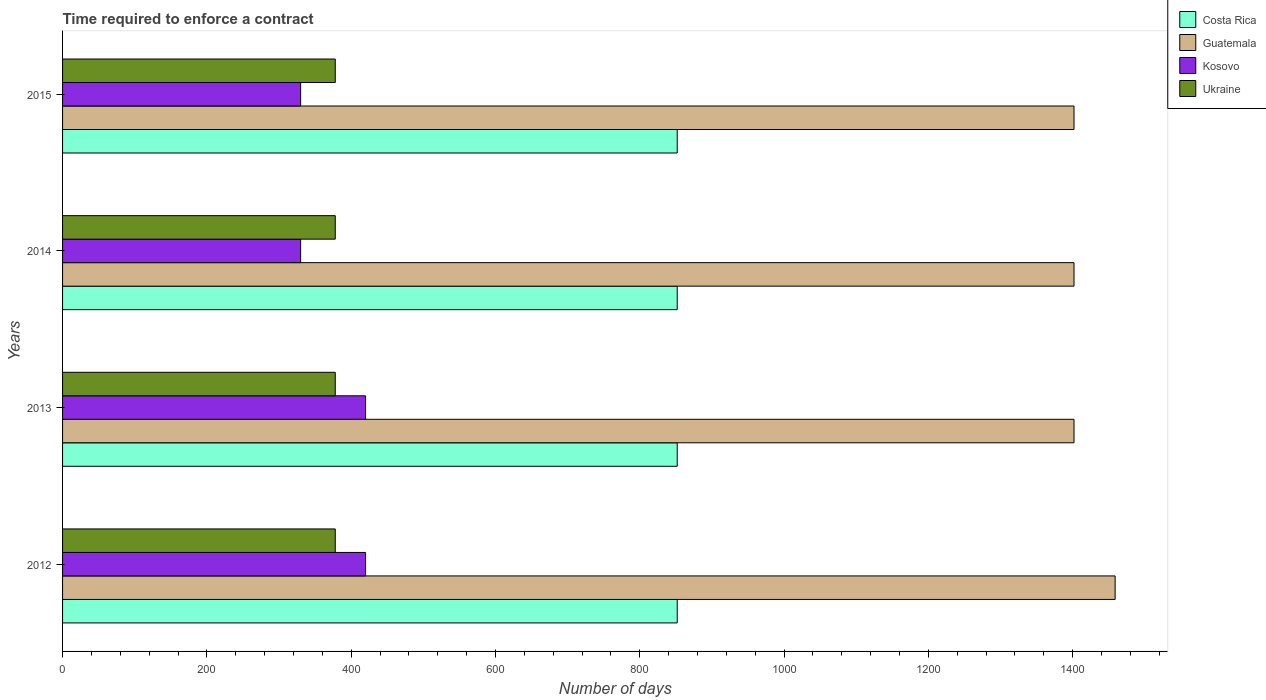Are the number of bars per tick equal to the number of legend labels?
Your answer should be compact. Yes. What is the label of the 4th group of bars from the top?
Offer a terse response. 2012. What is the number of days required to enforce a contract in Guatemala in 2014?
Your response must be concise. 1402. Across all years, what is the maximum number of days required to enforce a contract in Ukraine?
Give a very brief answer. 378. Across all years, what is the minimum number of days required to enforce a contract in Kosovo?
Ensure brevity in your answer.  330. In which year was the number of days required to enforce a contract in Guatemala maximum?
Make the answer very short. 2012. What is the total number of days required to enforce a contract in Ukraine in the graph?
Your answer should be compact. 1512. What is the difference between the number of days required to enforce a contract in Kosovo in 2014 and the number of days required to enforce a contract in Ukraine in 2013?
Provide a succinct answer. -48. What is the average number of days required to enforce a contract in Costa Rica per year?
Your response must be concise. 852. In the year 2014, what is the difference between the number of days required to enforce a contract in Ukraine and number of days required to enforce a contract in Costa Rica?
Provide a succinct answer. -474. What is the ratio of the number of days required to enforce a contract in Kosovo in 2012 to that in 2013?
Make the answer very short. 1. Is the difference between the number of days required to enforce a contract in Ukraine in 2013 and 2015 greater than the difference between the number of days required to enforce a contract in Costa Rica in 2013 and 2015?
Make the answer very short. No. What is the difference between the highest and the lowest number of days required to enforce a contract in Ukraine?
Provide a short and direct response. 0. Is the sum of the number of days required to enforce a contract in Kosovo in 2013 and 2015 greater than the maximum number of days required to enforce a contract in Guatemala across all years?
Your response must be concise. No. What does the 2nd bar from the top in 2014 represents?
Provide a short and direct response. Kosovo. What does the 4th bar from the bottom in 2014 represents?
Your response must be concise. Ukraine. Are all the bars in the graph horizontal?
Ensure brevity in your answer.  Yes. What is the difference between two consecutive major ticks on the X-axis?
Ensure brevity in your answer.  200. How many legend labels are there?
Keep it short and to the point. 4. How are the legend labels stacked?
Keep it short and to the point. Vertical. What is the title of the graph?
Offer a terse response. Time required to enforce a contract. Does "Saudi Arabia" appear as one of the legend labels in the graph?
Ensure brevity in your answer.  No. What is the label or title of the X-axis?
Ensure brevity in your answer.  Number of days. What is the label or title of the Y-axis?
Provide a succinct answer. Years. What is the Number of days in Costa Rica in 2012?
Make the answer very short. 852. What is the Number of days of Guatemala in 2012?
Keep it short and to the point. 1459. What is the Number of days of Kosovo in 2012?
Offer a very short reply. 420. What is the Number of days of Ukraine in 2012?
Offer a very short reply. 378. What is the Number of days in Costa Rica in 2013?
Make the answer very short. 852. What is the Number of days in Guatemala in 2013?
Provide a short and direct response. 1402. What is the Number of days in Kosovo in 2013?
Give a very brief answer. 420. What is the Number of days in Ukraine in 2013?
Offer a very short reply. 378. What is the Number of days in Costa Rica in 2014?
Offer a very short reply. 852. What is the Number of days in Guatemala in 2014?
Give a very brief answer. 1402. What is the Number of days in Kosovo in 2014?
Your answer should be compact. 330. What is the Number of days of Ukraine in 2014?
Provide a succinct answer. 378. What is the Number of days of Costa Rica in 2015?
Keep it short and to the point. 852. What is the Number of days in Guatemala in 2015?
Offer a terse response. 1402. What is the Number of days in Kosovo in 2015?
Your answer should be very brief. 330. What is the Number of days of Ukraine in 2015?
Your response must be concise. 378. Across all years, what is the maximum Number of days of Costa Rica?
Offer a terse response. 852. Across all years, what is the maximum Number of days of Guatemala?
Provide a succinct answer. 1459. Across all years, what is the maximum Number of days of Kosovo?
Keep it short and to the point. 420. Across all years, what is the maximum Number of days of Ukraine?
Provide a short and direct response. 378. Across all years, what is the minimum Number of days in Costa Rica?
Ensure brevity in your answer.  852. Across all years, what is the minimum Number of days in Guatemala?
Your answer should be compact. 1402. Across all years, what is the minimum Number of days in Kosovo?
Your response must be concise. 330. Across all years, what is the minimum Number of days of Ukraine?
Your answer should be compact. 378. What is the total Number of days in Costa Rica in the graph?
Your answer should be very brief. 3408. What is the total Number of days of Guatemala in the graph?
Your answer should be very brief. 5665. What is the total Number of days of Kosovo in the graph?
Your response must be concise. 1500. What is the total Number of days of Ukraine in the graph?
Your answer should be very brief. 1512. What is the difference between the Number of days in Costa Rica in 2012 and that in 2014?
Offer a terse response. 0. What is the difference between the Number of days of Guatemala in 2012 and that in 2014?
Offer a very short reply. 57. What is the difference between the Number of days in Costa Rica in 2012 and that in 2015?
Your response must be concise. 0. What is the difference between the Number of days of Kosovo in 2013 and that in 2014?
Offer a terse response. 90. What is the difference between the Number of days in Ukraine in 2013 and that in 2014?
Provide a succinct answer. 0. What is the difference between the Number of days in Guatemala in 2013 and that in 2015?
Provide a succinct answer. 0. What is the difference between the Number of days in Ukraine in 2013 and that in 2015?
Make the answer very short. 0. What is the difference between the Number of days of Costa Rica in 2014 and that in 2015?
Provide a succinct answer. 0. What is the difference between the Number of days in Guatemala in 2014 and that in 2015?
Provide a succinct answer. 0. What is the difference between the Number of days of Kosovo in 2014 and that in 2015?
Make the answer very short. 0. What is the difference between the Number of days of Costa Rica in 2012 and the Number of days of Guatemala in 2013?
Ensure brevity in your answer.  -550. What is the difference between the Number of days in Costa Rica in 2012 and the Number of days in Kosovo in 2013?
Your answer should be compact. 432. What is the difference between the Number of days of Costa Rica in 2012 and the Number of days of Ukraine in 2013?
Ensure brevity in your answer.  474. What is the difference between the Number of days of Guatemala in 2012 and the Number of days of Kosovo in 2013?
Your answer should be very brief. 1039. What is the difference between the Number of days in Guatemala in 2012 and the Number of days in Ukraine in 2013?
Provide a succinct answer. 1081. What is the difference between the Number of days in Costa Rica in 2012 and the Number of days in Guatemala in 2014?
Offer a terse response. -550. What is the difference between the Number of days of Costa Rica in 2012 and the Number of days of Kosovo in 2014?
Your response must be concise. 522. What is the difference between the Number of days of Costa Rica in 2012 and the Number of days of Ukraine in 2014?
Ensure brevity in your answer.  474. What is the difference between the Number of days in Guatemala in 2012 and the Number of days in Kosovo in 2014?
Provide a succinct answer. 1129. What is the difference between the Number of days in Guatemala in 2012 and the Number of days in Ukraine in 2014?
Provide a succinct answer. 1081. What is the difference between the Number of days of Kosovo in 2012 and the Number of days of Ukraine in 2014?
Keep it short and to the point. 42. What is the difference between the Number of days in Costa Rica in 2012 and the Number of days in Guatemala in 2015?
Your response must be concise. -550. What is the difference between the Number of days of Costa Rica in 2012 and the Number of days of Kosovo in 2015?
Your response must be concise. 522. What is the difference between the Number of days of Costa Rica in 2012 and the Number of days of Ukraine in 2015?
Make the answer very short. 474. What is the difference between the Number of days in Guatemala in 2012 and the Number of days in Kosovo in 2015?
Ensure brevity in your answer.  1129. What is the difference between the Number of days of Guatemala in 2012 and the Number of days of Ukraine in 2015?
Your answer should be very brief. 1081. What is the difference between the Number of days of Kosovo in 2012 and the Number of days of Ukraine in 2015?
Provide a short and direct response. 42. What is the difference between the Number of days of Costa Rica in 2013 and the Number of days of Guatemala in 2014?
Provide a succinct answer. -550. What is the difference between the Number of days of Costa Rica in 2013 and the Number of days of Kosovo in 2014?
Give a very brief answer. 522. What is the difference between the Number of days of Costa Rica in 2013 and the Number of days of Ukraine in 2014?
Offer a terse response. 474. What is the difference between the Number of days of Guatemala in 2013 and the Number of days of Kosovo in 2014?
Your answer should be very brief. 1072. What is the difference between the Number of days in Guatemala in 2013 and the Number of days in Ukraine in 2014?
Provide a succinct answer. 1024. What is the difference between the Number of days in Kosovo in 2013 and the Number of days in Ukraine in 2014?
Ensure brevity in your answer.  42. What is the difference between the Number of days in Costa Rica in 2013 and the Number of days in Guatemala in 2015?
Your answer should be compact. -550. What is the difference between the Number of days in Costa Rica in 2013 and the Number of days in Kosovo in 2015?
Your response must be concise. 522. What is the difference between the Number of days of Costa Rica in 2013 and the Number of days of Ukraine in 2015?
Offer a terse response. 474. What is the difference between the Number of days in Guatemala in 2013 and the Number of days in Kosovo in 2015?
Your answer should be very brief. 1072. What is the difference between the Number of days of Guatemala in 2013 and the Number of days of Ukraine in 2015?
Provide a short and direct response. 1024. What is the difference between the Number of days of Costa Rica in 2014 and the Number of days of Guatemala in 2015?
Provide a succinct answer. -550. What is the difference between the Number of days in Costa Rica in 2014 and the Number of days in Kosovo in 2015?
Your answer should be compact. 522. What is the difference between the Number of days of Costa Rica in 2014 and the Number of days of Ukraine in 2015?
Provide a short and direct response. 474. What is the difference between the Number of days in Guatemala in 2014 and the Number of days in Kosovo in 2015?
Your answer should be compact. 1072. What is the difference between the Number of days of Guatemala in 2014 and the Number of days of Ukraine in 2015?
Your response must be concise. 1024. What is the difference between the Number of days of Kosovo in 2014 and the Number of days of Ukraine in 2015?
Your answer should be very brief. -48. What is the average Number of days in Costa Rica per year?
Make the answer very short. 852. What is the average Number of days in Guatemala per year?
Your answer should be very brief. 1416.25. What is the average Number of days in Kosovo per year?
Offer a very short reply. 375. What is the average Number of days of Ukraine per year?
Provide a succinct answer. 378. In the year 2012, what is the difference between the Number of days in Costa Rica and Number of days in Guatemala?
Provide a short and direct response. -607. In the year 2012, what is the difference between the Number of days of Costa Rica and Number of days of Kosovo?
Ensure brevity in your answer.  432. In the year 2012, what is the difference between the Number of days of Costa Rica and Number of days of Ukraine?
Your answer should be very brief. 474. In the year 2012, what is the difference between the Number of days in Guatemala and Number of days in Kosovo?
Give a very brief answer. 1039. In the year 2012, what is the difference between the Number of days in Guatemala and Number of days in Ukraine?
Your answer should be very brief. 1081. In the year 2013, what is the difference between the Number of days in Costa Rica and Number of days in Guatemala?
Keep it short and to the point. -550. In the year 2013, what is the difference between the Number of days of Costa Rica and Number of days of Kosovo?
Make the answer very short. 432. In the year 2013, what is the difference between the Number of days in Costa Rica and Number of days in Ukraine?
Provide a succinct answer. 474. In the year 2013, what is the difference between the Number of days of Guatemala and Number of days of Kosovo?
Give a very brief answer. 982. In the year 2013, what is the difference between the Number of days of Guatemala and Number of days of Ukraine?
Make the answer very short. 1024. In the year 2013, what is the difference between the Number of days in Kosovo and Number of days in Ukraine?
Provide a short and direct response. 42. In the year 2014, what is the difference between the Number of days in Costa Rica and Number of days in Guatemala?
Provide a succinct answer. -550. In the year 2014, what is the difference between the Number of days of Costa Rica and Number of days of Kosovo?
Provide a succinct answer. 522. In the year 2014, what is the difference between the Number of days of Costa Rica and Number of days of Ukraine?
Offer a terse response. 474. In the year 2014, what is the difference between the Number of days of Guatemala and Number of days of Kosovo?
Your response must be concise. 1072. In the year 2014, what is the difference between the Number of days in Guatemala and Number of days in Ukraine?
Your answer should be very brief. 1024. In the year 2014, what is the difference between the Number of days in Kosovo and Number of days in Ukraine?
Your answer should be compact. -48. In the year 2015, what is the difference between the Number of days in Costa Rica and Number of days in Guatemala?
Give a very brief answer. -550. In the year 2015, what is the difference between the Number of days in Costa Rica and Number of days in Kosovo?
Make the answer very short. 522. In the year 2015, what is the difference between the Number of days of Costa Rica and Number of days of Ukraine?
Offer a terse response. 474. In the year 2015, what is the difference between the Number of days of Guatemala and Number of days of Kosovo?
Give a very brief answer. 1072. In the year 2015, what is the difference between the Number of days of Guatemala and Number of days of Ukraine?
Ensure brevity in your answer.  1024. In the year 2015, what is the difference between the Number of days in Kosovo and Number of days in Ukraine?
Make the answer very short. -48. What is the ratio of the Number of days in Costa Rica in 2012 to that in 2013?
Keep it short and to the point. 1. What is the ratio of the Number of days in Guatemala in 2012 to that in 2013?
Your answer should be very brief. 1.04. What is the ratio of the Number of days in Kosovo in 2012 to that in 2013?
Give a very brief answer. 1. What is the ratio of the Number of days of Guatemala in 2012 to that in 2014?
Your answer should be very brief. 1.04. What is the ratio of the Number of days of Kosovo in 2012 to that in 2014?
Provide a succinct answer. 1.27. What is the ratio of the Number of days in Ukraine in 2012 to that in 2014?
Make the answer very short. 1. What is the ratio of the Number of days in Guatemala in 2012 to that in 2015?
Your response must be concise. 1.04. What is the ratio of the Number of days in Kosovo in 2012 to that in 2015?
Your response must be concise. 1.27. What is the ratio of the Number of days in Ukraine in 2012 to that in 2015?
Offer a terse response. 1. What is the ratio of the Number of days of Costa Rica in 2013 to that in 2014?
Your answer should be very brief. 1. What is the ratio of the Number of days in Guatemala in 2013 to that in 2014?
Your answer should be very brief. 1. What is the ratio of the Number of days of Kosovo in 2013 to that in 2014?
Your answer should be very brief. 1.27. What is the ratio of the Number of days of Ukraine in 2013 to that in 2014?
Ensure brevity in your answer.  1. What is the ratio of the Number of days of Costa Rica in 2013 to that in 2015?
Ensure brevity in your answer.  1. What is the ratio of the Number of days in Kosovo in 2013 to that in 2015?
Provide a succinct answer. 1.27. What is the ratio of the Number of days of Ukraine in 2013 to that in 2015?
Offer a terse response. 1. What is the ratio of the Number of days of Costa Rica in 2014 to that in 2015?
Your response must be concise. 1. What is the ratio of the Number of days in Guatemala in 2014 to that in 2015?
Give a very brief answer. 1. What is the difference between the highest and the second highest Number of days in Costa Rica?
Your answer should be very brief. 0. What is the difference between the highest and the second highest Number of days of Guatemala?
Offer a very short reply. 57. What is the difference between the highest and the second highest Number of days in Kosovo?
Provide a succinct answer. 0. What is the difference between the highest and the second highest Number of days in Ukraine?
Give a very brief answer. 0. What is the difference between the highest and the lowest Number of days of Guatemala?
Provide a succinct answer. 57. What is the difference between the highest and the lowest Number of days of Ukraine?
Offer a very short reply. 0. 